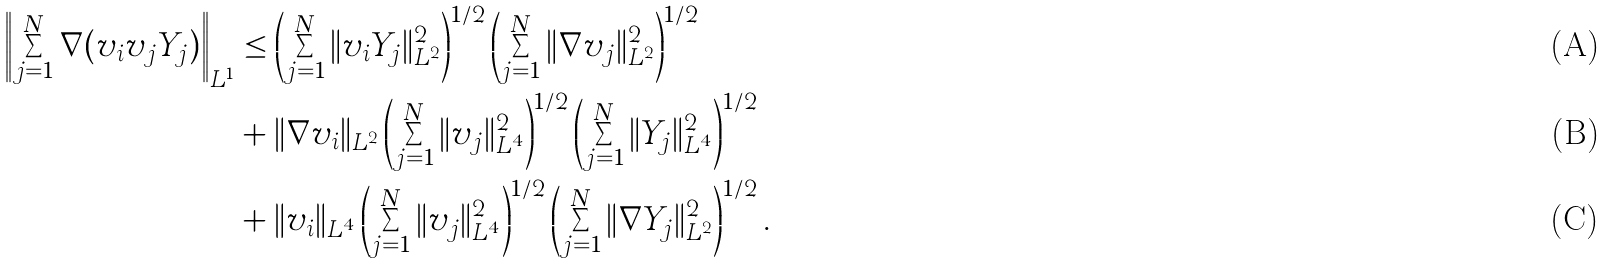Convert formula to latex. <formula><loc_0><loc_0><loc_500><loc_500>\left \| \sum _ { j = 1 } ^ { N } \nabla ( v _ { i } v _ { j } Y _ { j } ) \right \| _ { L ^ { 1 } } & \leq \left ( \sum _ { j = 1 } ^ { N } \| v _ { i } Y _ { j } \| _ { L ^ { 2 } } ^ { 2 } \right ) ^ { 1 / 2 } \left ( \sum _ { j = 1 } ^ { N } \| \nabla v _ { j } \| _ { L ^ { 2 } } ^ { 2 } \right ) ^ { 1 / 2 } \\ & + \| \nabla v _ { i } \| _ { L ^ { 2 } } \left ( \sum _ { j = 1 } ^ { N } \| v _ { j } \| _ { L ^ { 4 } } ^ { 2 } \right ) ^ { 1 / 2 } \left ( \sum _ { j = 1 } ^ { N } \| Y _ { j } \| _ { L ^ { 4 } } ^ { 2 } \right ) ^ { 1 / 2 } \\ & + \| v _ { i } \| _ { L ^ { 4 } } \left ( \sum _ { j = 1 } ^ { N } \| v _ { j } \| _ { L ^ { 4 } } ^ { 2 } \right ) ^ { 1 / 2 } \left ( \sum _ { j = 1 } ^ { N } \| \nabla Y _ { j } \| _ { L ^ { 2 } } ^ { 2 } \right ) ^ { 1 / 2 } .</formula> 